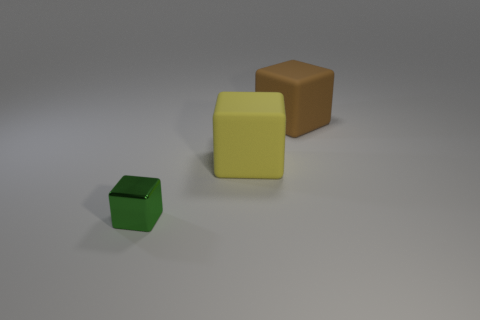How big is the cube that is behind the big rubber object that is in front of the large brown thing?
Your answer should be very brief. Large. Do the matte object behind the big yellow cube and the small block on the left side of the yellow matte block have the same color?
Your answer should be very brief. No. How many large matte cubes are on the right side of the rubber thing that is in front of the cube behind the large yellow cube?
Offer a terse response. 1. How many blocks are both on the right side of the green thing and left of the big brown block?
Your answer should be compact. 1. Are there more tiny green shiny cubes behind the green shiny block than brown objects?
Make the answer very short. No. What number of yellow blocks have the same size as the green metallic block?
Provide a succinct answer. 0. How many big things are metal cubes or blue spheres?
Your answer should be very brief. 0. How many tiny rubber balls are there?
Keep it short and to the point. 0. Is the number of yellow matte objects that are in front of the yellow matte object the same as the number of tiny green metal cubes that are left of the brown rubber block?
Keep it short and to the point. No. There is a large yellow rubber object; are there any yellow rubber objects right of it?
Keep it short and to the point. No. 